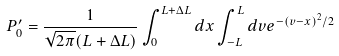Convert formula to latex. <formula><loc_0><loc_0><loc_500><loc_500>P ^ { \prime } _ { 0 } = \frac { 1 } { \sqrt { 2 \pi } ( L + { \Delta L } ) } \int _ { 0 } ^ { L + { \Delta L } } d x \int _ { - L } ^ { L } d v e ^ { - ( v - x ) ^ { 2 } / 2 }</formula> 